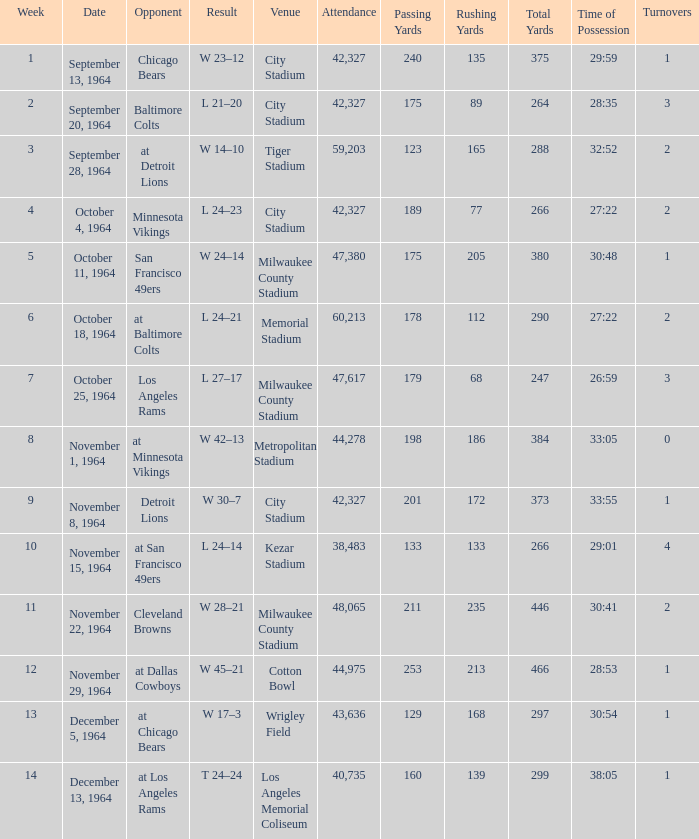What is the average week of the game on November 22, 1964 attended by 48,065? None. Could you parse the entire table? {'header': ['Week', 'Date', 'Opponent', 'Result', 'Venue', 'Attendance', 'Passing Yards', 'Rushing Yards', 'Total Yards', 'Time of Possession', 'Turnovers'], 'rows': [['1', 'September 13, 1964', 'Chicago Bears', 'W 23–12', 'City Stadium', '42,327', '240', '135', '375', '29:59', '1'], ['2', 'September 20, 1964', 'Baltimore Colts', 'L 21–20', 'City Stadium', '42,327', '175', '89', '264', '28:35', '3'], ['3', 'September 28, 1964', 'at Detroit Lions', 'W 14–10', 'Tiger Stadium', '59,203', '123', '165', '288', '32:52', '2'], ['4', 'October 4, 1964', 'Minnesota Vikings', 'L 24–23', 'City Stadium', '42,327', '189', '77', '266', '27:22', '2'], ['5', 'October 11, 1964', 'San Francisco 49ers', 'W 24–14', 'Milwaukee County Stadium', '47,380', '175', '205', '380', '30:48', '1'], ['6', 'October 18, 1964', 'at Baltimore Colts', 'L 24–21', 'Memorial Stadium', '60,213', '178', '112', '290', '27:22', '2'], ['7', 'October 25, 1964', 'Los Angeles Rams', 'L 27–17', 'Milwaukee County Stadium', '47,617', '179', '68', '247', '26:59', '3'], ['8', 'November 1, 1964', 'at Minnesota Vikings', 'W 42–13', 'Metropolitan Stadium', '44,278', '198', '186', '384', '33:05', '0'], ['9', 'November 8, 1964', 'Detroit Lions', 'W 30–7', 'City Stadium', '42,327', '201', '172', '373', '33:55', '1'], ['10', 'November 15, 1964', 'at San Francisco 49ers', 'L 24–14', 'Kezar Stadium', '38,483', '133', '133', '266', '29:01', '4'], ['11', 'November 22, 1964', 'Cleveland Browns', 'W 28–21', 'Milwaukee County Stadium', '48,065', '211', '235', '446', '30:41', '2'], ['12', 'November 29, 1964', 'at Dallas Cowboys', 'W 45–21', 'Cotton Bowl', '44,975', '253', '213', '466', '28:53', '1'], ['13', 'December 5, 1964', 'at Chicago Bears', 'W 17–3', 'Wrigley Field', '43,636', '129', '168', '297', '30:54', '1'], ['14', 'December 13, 1964', 'at Los Angeles Rams', 'T 24–24', 'Los Angeles Memorial Coliseum', '40,735', '160', '139', '299', '38:05', '1']]} 